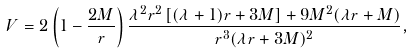<formula> <loc_0><loc_0><loc_500><loc_500>V = 2 \left ( 1 - \frac { 2 M } { r } \right ) { \frac { \lambda ^ { 2 } r ^ { 2 } \left [ ( \lambda + 1 ) r + 3 M \right ] + 9 M ^ { 2 } ( \lambda r + M ) } { r ^ { 3 } ( \lambda r + 3 M ) ^ { 2 } } } ,</formula> 